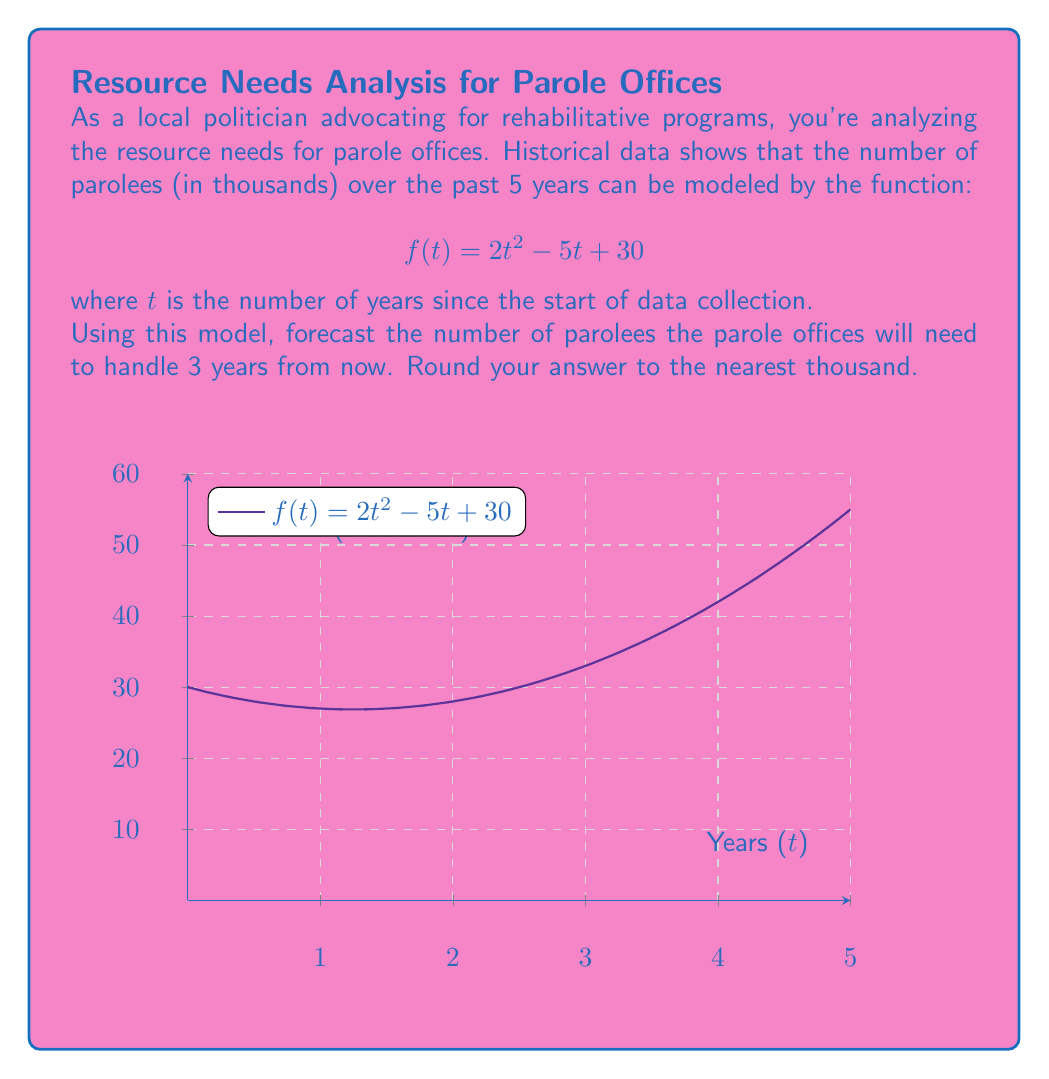Teach me how to tackle this problem. To solve this problem, we'll follow these steps:

1) We're given the function $f(t) = 2t^2 - 5t + 30$, where $t$ is the number of years since data collection started.

2) We need to forecast 3 years from now. Since we've already collected 5 years of data, we need to calculate $f(8)$.

3) Let's substitute $t = 8$ into our function:

   $f(8) = 2(8)^2 - 5(8) + 30$

4) Now, let's calculate step by step:
   
   $f(8) = 2(64) - 40 + 30$
   $f(8) = 128 - 40 + 30$
   $f(8) = 118$

5) The result, 118, represents 118 thousand parolees.

6) Rounding to the nearest thousand gives us 118 thousand.

This forecast suggests that parole offices should prepare resources to handle approximately 118,000 parolees three years from now, a significant increase from the current numbers. This information can be used to advocate for increased funding and resources for rehabilitative programs.
Answer: 118,000 parolees 